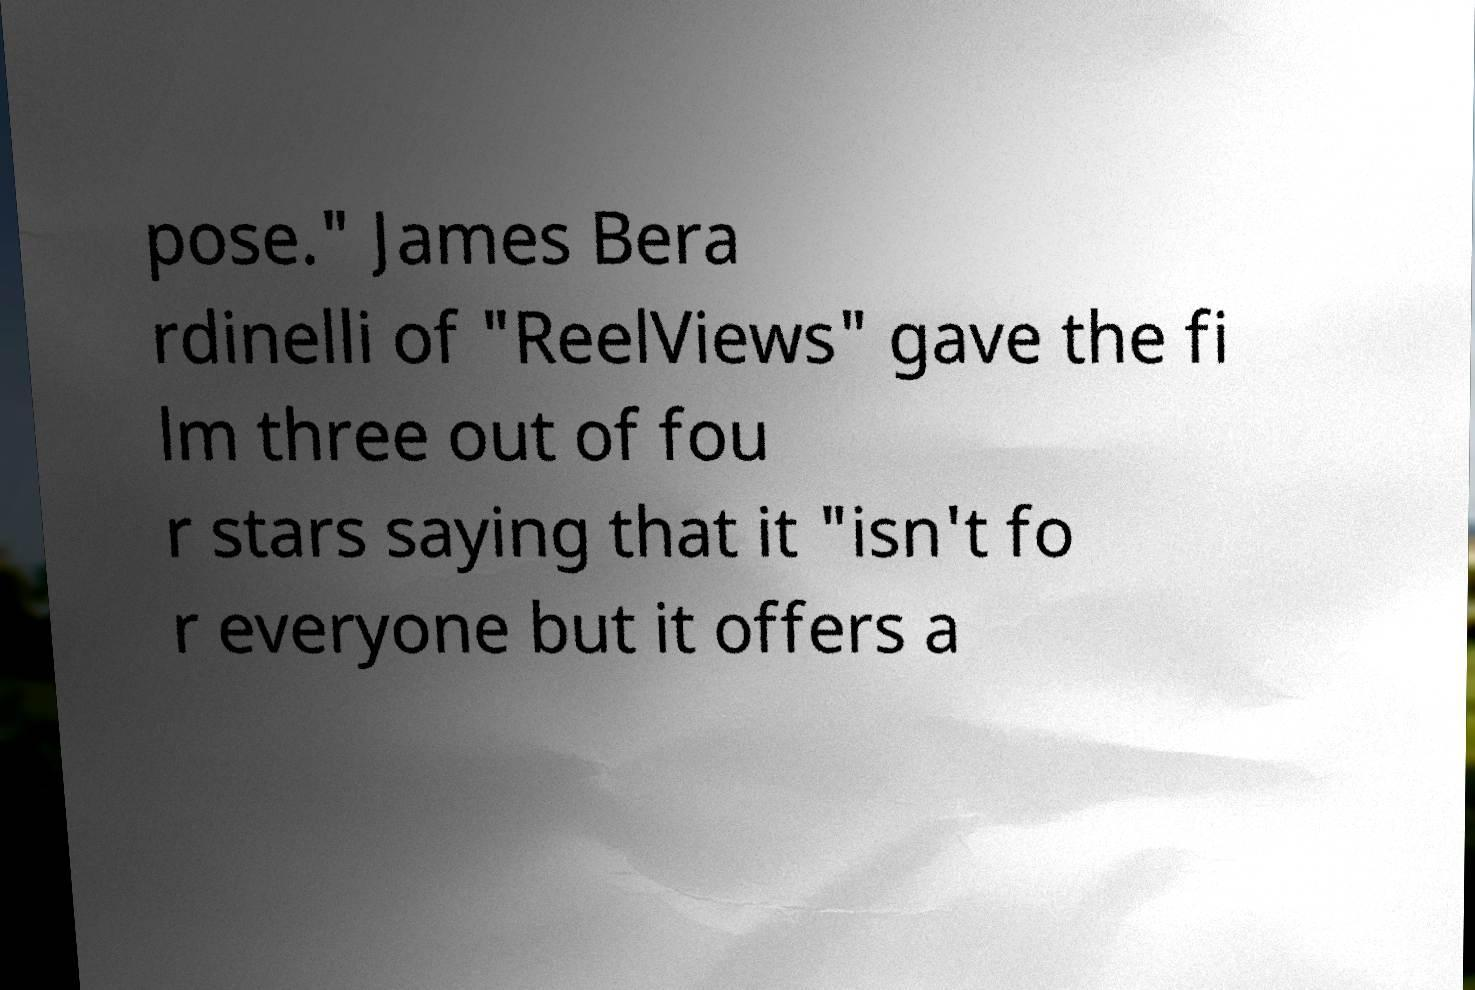What messages or text are displayed in this image? I need them in a readable, typed format. pose." James Bera rdinelli of "ReelViews" gave the fi lm three out of fou r stars saying that it "isn't fo r everyone but it offers a 